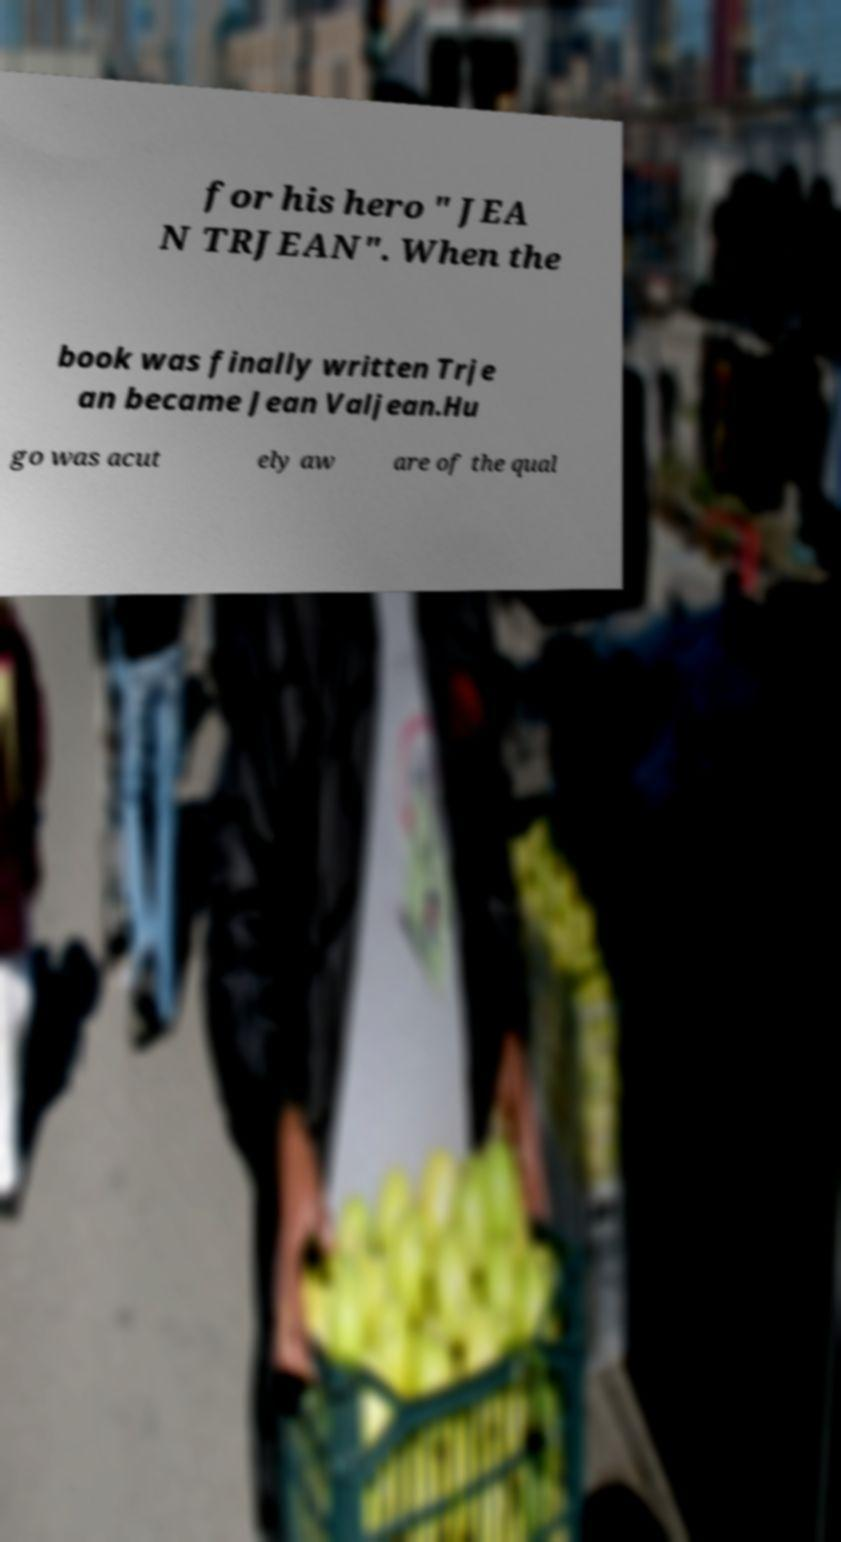Please read and relay the text visible in this image. What does it say? for his hero " JEA N TRJEAN". When the book was finally written Trje an became Jean Valjean.Hu go was acut ely aw are of the qual 